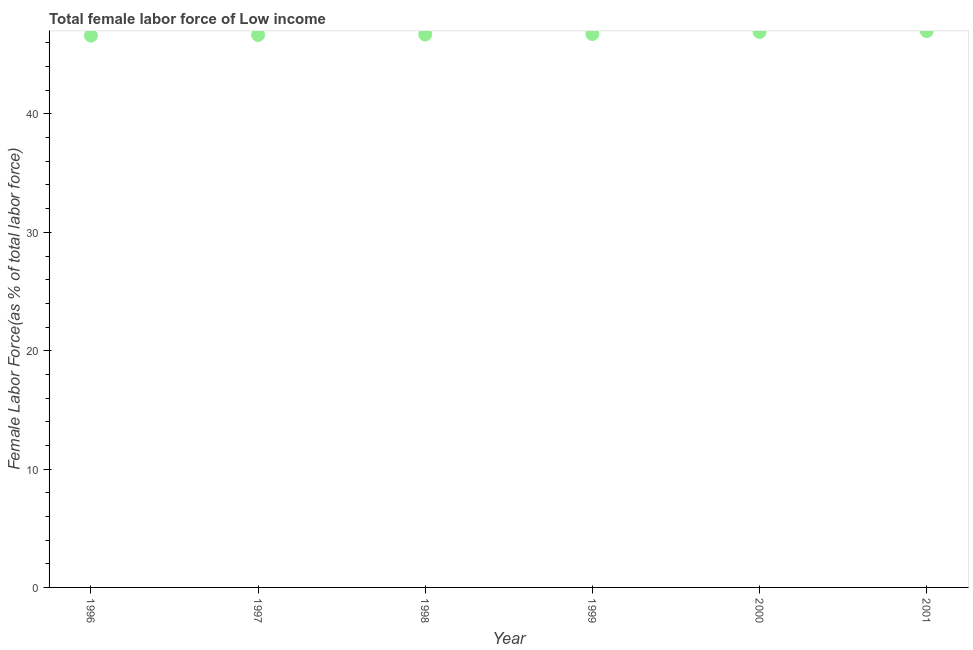What is the total female labor force in 1996?
Give a very brief answer. 46.62. Across all years, what is the maximum total female labor force?
Make the answer very short. 47. Across all years, what is the minimum total female labor force?
Your answer should be very brief. 46.62. What is the sum of the total female labor force?
Provide a short and direct response. 280.7. What is the difference between the total female labor force in 1997 and 2001?
Provide a short and direct response. -0.33. What is the average total female labor force per year?
Provide a succinct answer. 46.78. What is the median total female labor force?
Make the answer very short. 46.73. Do a majority of the years between 1999 and 1996 (inclusive) have total female labor force greater than 24 %?
Offer a terse response. Yes. What is the ratio of the total female labor force in 1997 to that in 1999?
Provide a succinct answer. 1. Is the total female labor force in 1998 less than that in 2000?
Provide a short and direct response. Yes. What is the difference between the highest and the second highest total female labor force?
Offer a very short reply. 0.07. Is the sum of the total female labor force in 1997 and 2000 greater than the maximum total female labor force across all years?
Provide a succinct answer. Yes. What is the difference between the highest and the lowest total female labor force?
Make the answer very short. 0.38. Does the total female labor force monotonically increase over the years?
Your response must be concise. Yes. Are the values on the major ticks of Y-axis written in scientific E-notation?
Provide a succinct answer. No. What is the title of the graph?
Keep it short and to the point. Total female labor force of Low income. What is the label or title of the Y-axis?
Offer a very short reply. Female Labor Force(as % of total labor force). What is the Female Labor Force(as % of total labor force) in 1996?
Provide a short and direct response. 46.62. What is the Female Labor Force(as % of total labor force) in 1997?
Your response must be concise. 46.67. What is the Female Labor Force(as % of total labor force) in 1998?
Your answer should be compact. 46.71. What is the Female Labor Force(as % of total labor force) in 1999?
Your answer should be compact. 46.75. What is the Female Labor Force(as % of total labor force) in 2000?
Keep it short and to the point. 46.93. What is the Female Labor Force(as % of total labor force) in 2001?
Your answer should be compact. 47. What is the difference between the Female Labor Force(as % of total labor force) in 1996 and 1997?
Offer a very short reply. -0.05. What is the difference between the Female Labor Force(as % of total labor force) in 1996 and 1998?
Your response must be concise. -0.09. What is the difference between the Female Labor Force(as % of total labor force) in 1996 and 1999?
Ensure brevity in your answer.  -0.13. What is the difference between the Female Labor Force(as % of total labor force) in 1996 and 2000?
Ensure brevity in your answer.  -0.31. What is the difference between the Female Labor Force(as % of total labor force) in 1996 and 2001?
Give a very brief answer. -0.38. What is the difference between the Female Labor Force(as % of total labor force) in 1997 and 1998?
Ensure brevity in your answer.  -0.04. What is the difference between the Female Labor Force(as % of total labor force) in 1997 and 1999?
Your answer should be compact. -0.08. What is the difference between the Female Labor Force(as % of total labor force) in 1997 and 2000?
Offer a terse response. -0.26. What is the difference between the Female Labor Force(as % of total labor force) in 1997 and 2001?
Ensure brevity in your answer.  -0.33. What is the difference between the Female Labor Force(as % of total labor force) in 1998 and 1999?
Keep it short and to the point. -0.04. What is the difference between the Female Labor Force(as % of total labor force) in 1998 and 2000?
Ensure brevity in your answer.  -0.22. What is the difference between the Female Labor Force(as % of total labor force) in 1998 and 2001?
Offer a very short reply. -0.29. What is the difference between the Female Labor Force(as % of total labor force) in 1999 and 2000?
Your response must be concise. -0.18. What is the difference between the Female Labor Force(as % of total labor force) in 1999 and 2001?
Ensure brevity in your answer.  -0.25. What is the difference between the Female Labor Force(as % of total labor force) in 2000 and 2001?
Your answer should be compact. -0.07. What is the ratio of the Female Labor Force(as % of total labor force) in 1996 to that in 1998?
Make the answer very short. 1. What is the ratio of the Female Labor Force(as % of total labor force) in 1996 to that in 1999?
Your answer should be very brief. 1. What is the ratio of the Female Labor Force(as % of total labor force) in 1996 to that in 2001?
Offer a very short reply. 0.99. What is the ratio of the Female Labor Force(as % of total labor force) in 1997 to that in 2001?
Your response must be concise. 0.99. What is the ratio of the Female Labor Force(as % of total labor force) in 1998 to that in 1999?
Your response must be concise. 1. What is the ratio of the Female Labor Force(as % of total labor force) in 1998 to that in 2000?
Your answer should be very brief. 0.99. What is the ratio of the Female Labor Force(as % of total labor force) in 1999 to that in 2000?
Ensure brevity in your answer.  1. What is the ratio of the Female Labor Force(as % of total labor force) in 1999 to that in 2001?
Provide a short and direct response. 0.99. 